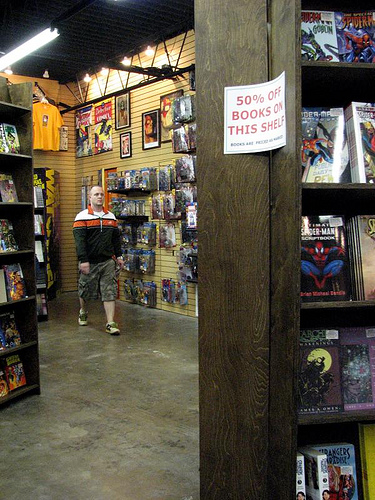<image>
Can you confirm if the man is in front of the bookshelf? No. The man is not in front of the bookshelf. The spatial positioning shows a different relationship between these objects. 